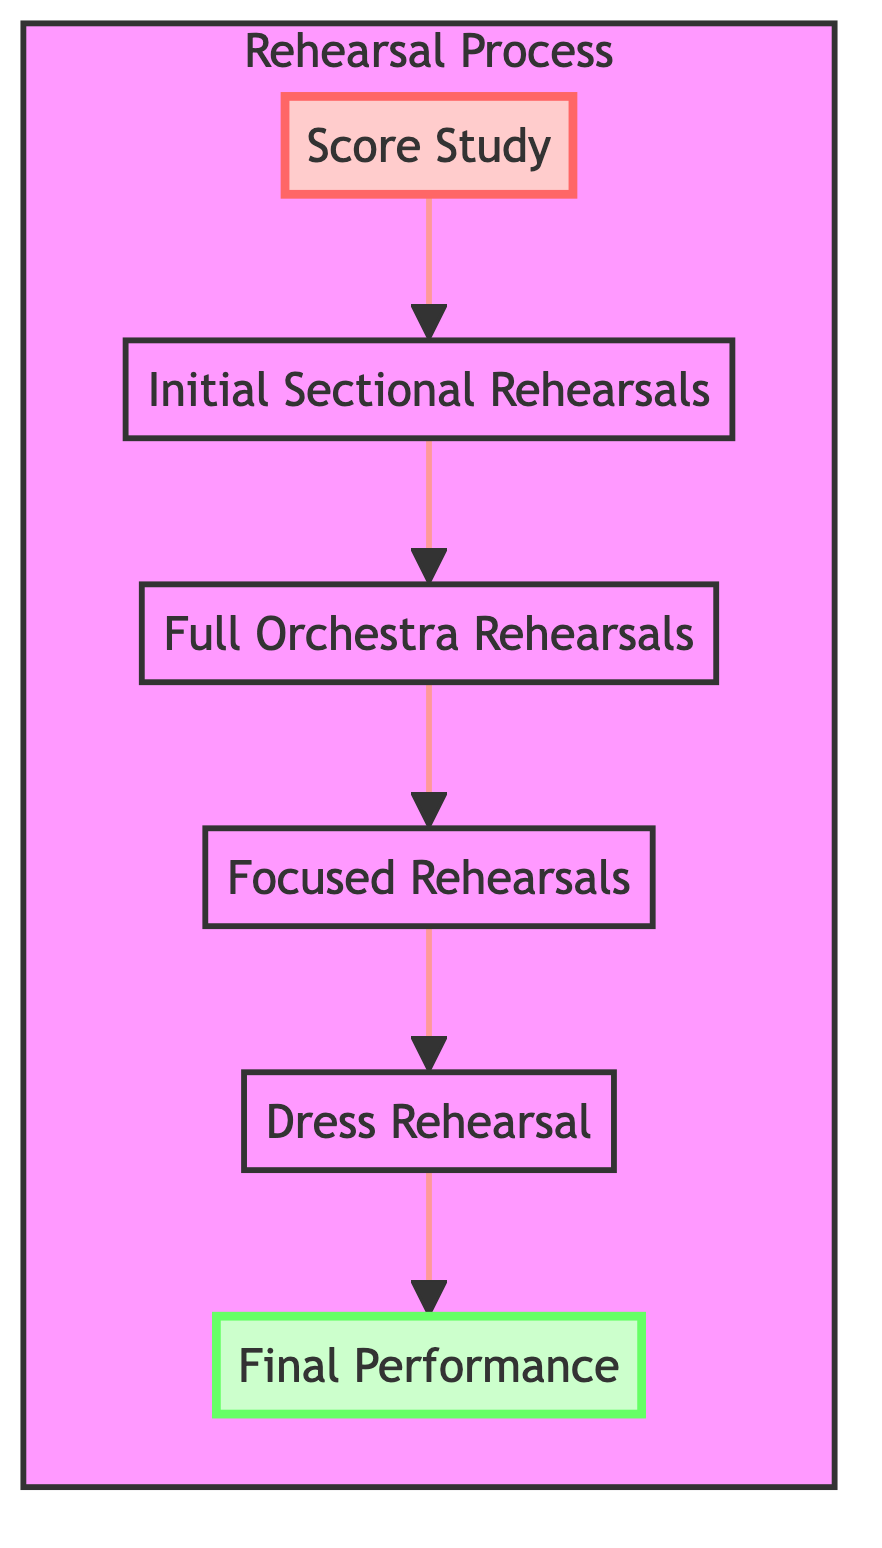What is the first step in the rehearsal process? The diagram shows that the first step is "Score Study," which is at the bottom of the flow chart.
Answer: Score Study How many total steps are there in the rehearsal process? The diagram lists a total of six distinct steps from "Score Study" to "Final Performance," represented as nodes in the flow chart.
Answer: Six What step comes after "Initial Sectional Rehearsals"? By following the arrows in the diagram, "Full Orchestra Rehearsals" is the next step that follows "Initial Sectional Rehearsals."
Answer: Full Orchestra Rehearsals What is the final step of the process? The last node in the diagram, which is at the top, is "Final Performance," signifying it is the concluding step in the rehearsal process.
Answer: Final Performance Which step focuses on challenging passages? According to the diagram, the step dedicated to challenging passages is called "Focused Rehearsals," which precedes the "Dress Rehearsal" in the flow.
Answer: Focused Rehearsals What is the relationship between "Dress Rehearsal" and "Final Performance"? The diagram indicates that "Dress Rehearsal" directly leads into "Final Performance," demonstrating a sequential relationship in the rehearsal process.
Answer: Directly leads into How many sections are rehearsed during the "Initial Sectional Rehearsals" step? The diagram mentions that individual sections such as strings, woodwinds, brass, and percussion are rehearsed separately, totaling four distinct groups.
Answer: Four In which level is "Score Study" categorized? The diagram categorizes "Score Study" at level one, as it is the first step of the rehearsal process in the flow chart.
Answer: Level one What type of rehearsal immediately precedes the "Final Performance"? The flow chart shows that the step just before "Final Performance" is "Dress Rehearsal," indicating it is the final preparation step.
Answer: Dress Rehearsal 